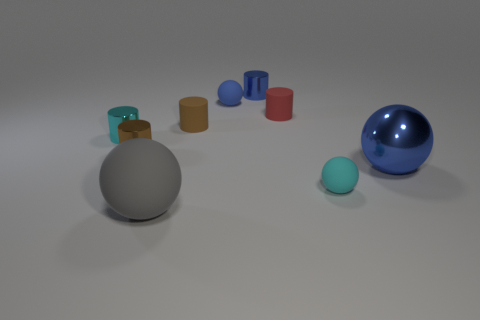There is a small blue object that is made of the same material as the tiny cyan cylinder; what shape is it?
Offer a terse response. Cylinder. What size is the blue sphere to the right of the small thing that is in front of the small brown shiny object?
Your answer should be very brief. Large. How many objects are either metal cylinders right of the brown metal thing or objects that are on the right side of the tiny brown shiny thing?
Your answer should be very brief. 7. Is the number of big cyan objects less than the number of cyan things?
Your answer should be compact. Yes. What number of things are either gray things or blue objects?
Make the answer very short. 4. Is the shape of the cyan matte thing the same as the gray rubber thing?
Provide a succinct answer. Yes. There is a brown cylinder that is on the right side of the large rubber ball; is its size the same as the blue metallic thing that is to the left of the big metallic object?
Make the answer very short. Yes. What is the material of the tiny cylinder that is both behind the brown metal cylinder and left of the large gray matte object?
Ensure brevity in your answer.  Metal. Are there any other things that are the same color as the large metal object?
Give a very brief answer. Yes. Is the number of large blue metal things that are to the left of the cyan matte object less than the number of large rubber cubes?
Offer a terse response. No. 